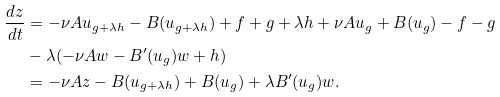Convert formula to latex. <formula><loc_0><loc_0><loc_500><loc_500>\frac { d z } { d t } & = - \nu A u _ { g + \lambda h } - B ( u _ { g + \lambda h } ) + f + g + \lambda h + \nu A u _ { g } + B ( u _ { g } ) - f - g \\ & - \lambda ( - \nu A w - B ^ { \prime } ( u _ { g } ) w + h ) \\ & = - \nu A z - B ( u _ { g + \lambda h } ) + B ( u _ { g } ) + \lambda B ^ { \prime } ( u _ { g } ) w .</formula> 